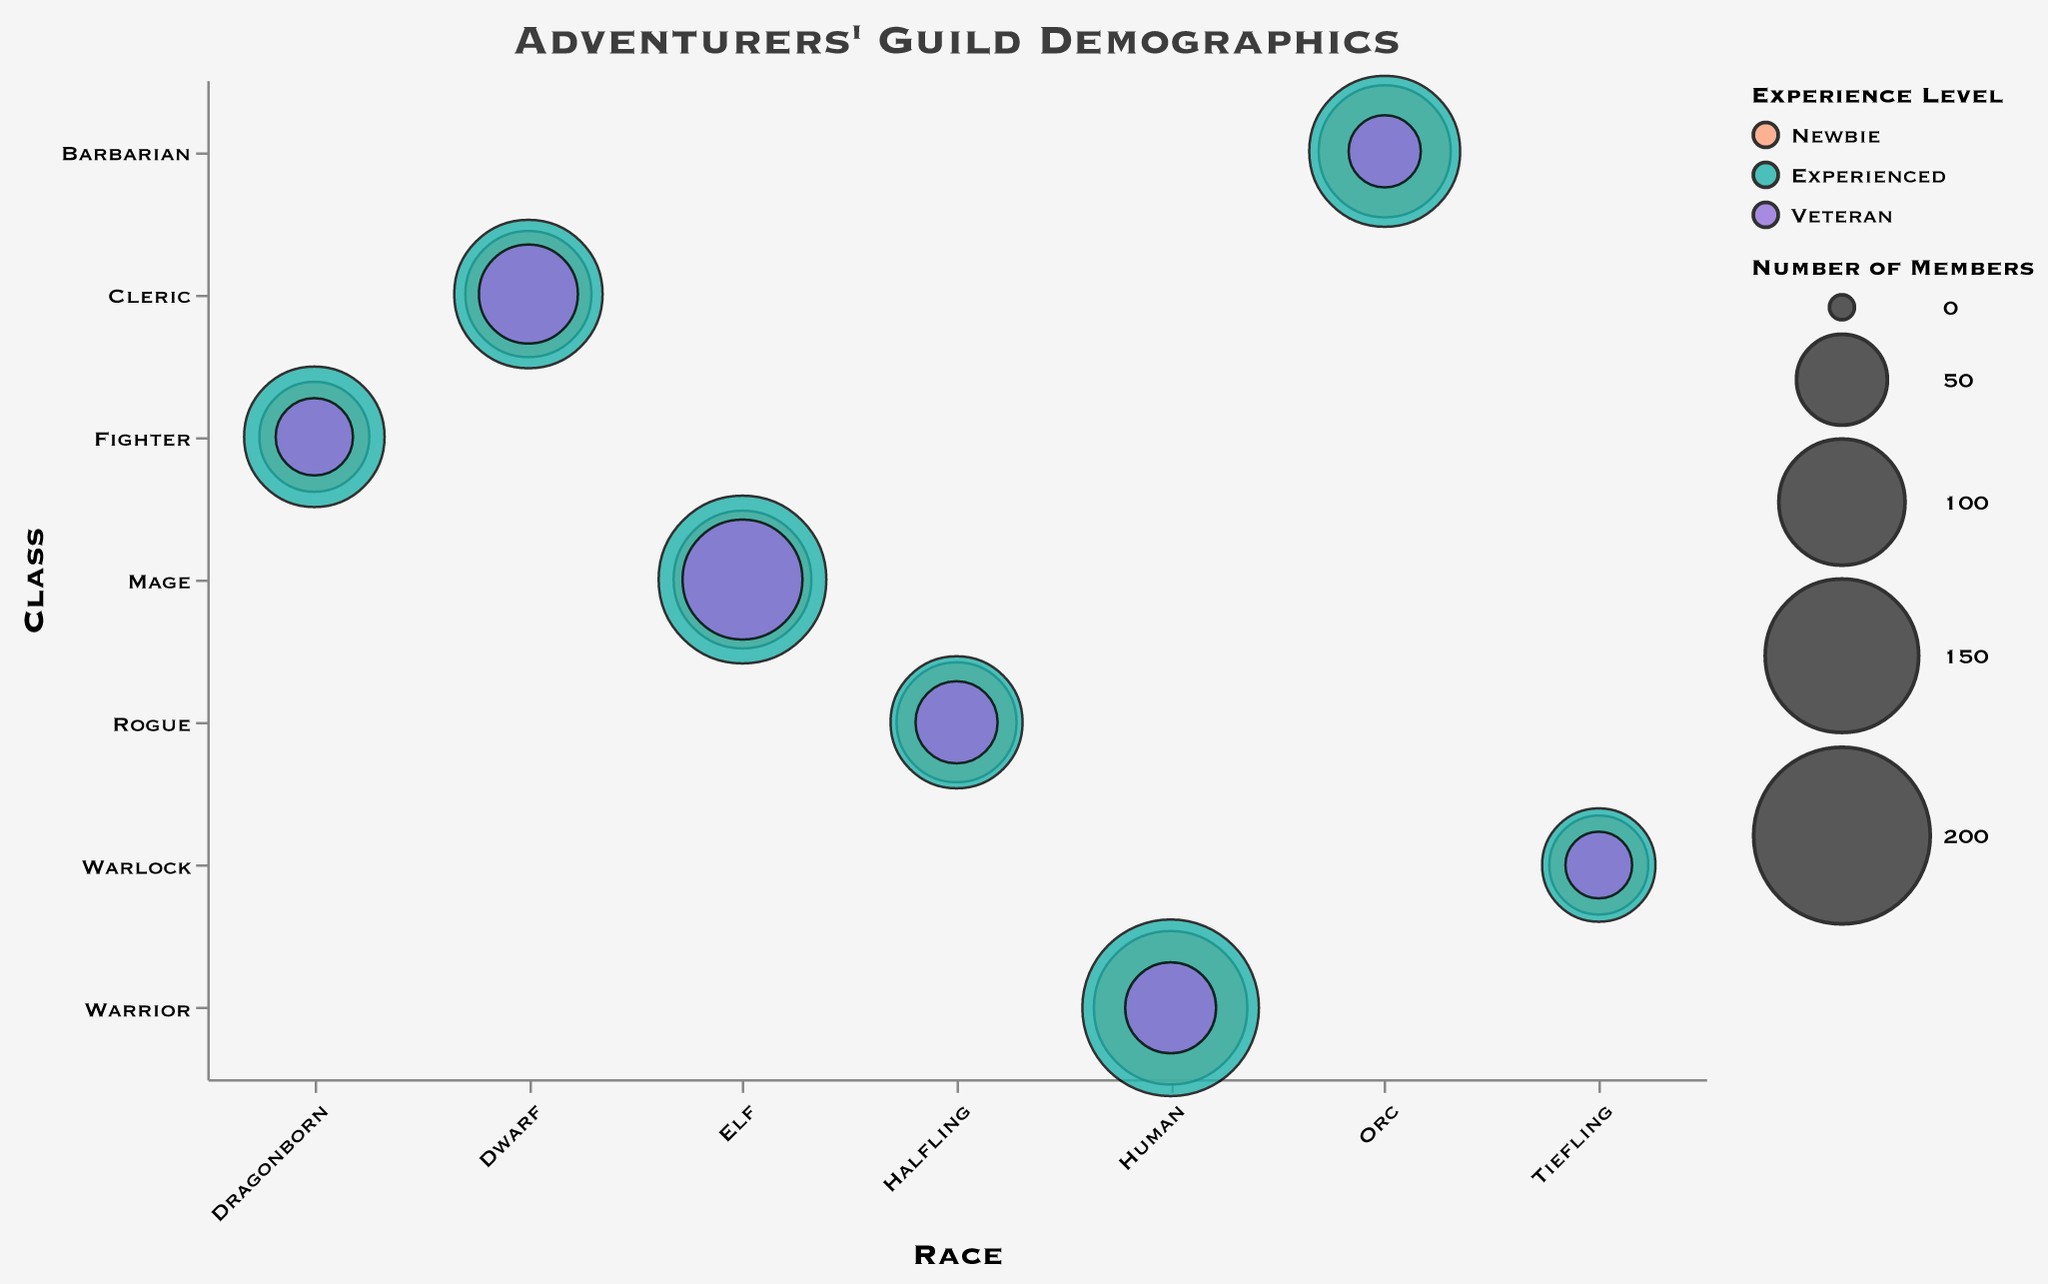What is the color representing the 'Experienced' experience level? The color for 'Experienced' experience level can be found by referring to the legend. The 'Experienced' level is shown in a teal color.
Answer: Teal How many 'Veteran' members are there in the 'Orc' race and 'Barbarian' class? Locate the bubble for the 'Orc' race and 'Barbarian' class with the 'Veteran' color. The tooltip or size will show the 'NumberOfMembers' value, which is 30.
Answer: 30 Which race-class-experience combination has the highest number of members? The largest bubble represents the highest number of members. By hovering over the largest bubble or checking the respective tooltip, we find it is the 'Human' race, 'Warrior' class, and 'Experienced' level. The 'NumberOfMembers' is 200.
Answer: Human-Warrior-Experienced Compare the number of 'Newbie' members between 'Elf' Mages and 'Human' Warriors. Which group has more members and by how much? First, identify the 'Newbie' bubbles for 'Elf' Mages and 'Human' Warriors by their position and color. The number of members for 'Elf' Mages is 120, and for 'Human' Warriors is 150. The difference is 150 - 120 = 30, so 'Human' Warriors have 30 more 'Newbie' members.
Answer: Human Warriors, by 30 What is the total number of members across all races and classes for the 'Veteran' experience level? Sum the 'NumberOfMembers' values for the 'Veteran' experience level across all race-class combinations. This includes: Human-Warrior (50), Elf-Mage (90), Dwarf-Cleric (60), Halfling-Rogue (40), Dragonborn-Fighter (35), Tiefling-Warlock (25), Orc-Barbarian (30). The total is 50 + 90 + 60 + 40 + 35 + 25 + 30 = 330.
Answer: 330 How does the 'Newbie' membership of 'Dragonborn' Fighters compare to 'Tiefling' Warlocks? Find the 'Newbie' bubbles for 'Dragonborn' Fighters and 'Tiefling' Warlocks. 'Dragonborn' Fighters have 75 members, while 'Tiefling' Warlocks have 60 members. Comparing these, 'Dragonborn' Fighters have more members.
Answer: Dragonborn Fighters have more members What are the race and class with the fewest 'Experienced' members, and how many members are there? Locate the smallest bubble for the 'Experienced' experience level across all race and class combinations. The smallest bubble is for the 'Tiefling' race and 'Warlock' class with 80 members.
Answer: Tiefling-Warlock, 80 members Which class has the highest number of total members regardless of race and experience level? Sum the 'NumberOfMembers' across all races and experience levels for each class and compare. The calculations for total are: 
- Warrior: 150 (Newbie) + 200 (Experienced) + 50 (Veteran) = 400
- Mage: 120 + 180 + 90 = 390
- Cleric: 100 + 140 + 60 = 300
- Rogue: 90 + 110 + 40 = 240
- Fighter: 75 + 125 + 35 = 235
- Warlock: 60 + 80 + 25 = 165
- Barbarian: 110 + 145 + 30 = 285
The class with the highest total is 'Warrior' with 400 members.
Answer: Warrior, 400 members How many 'Newbie' members are in the guild in total? Sum the 'NumberOfMembers' across all races and classes for the 'Newbie' experience level. This is: Human-Warrior (150), Elf-Mage (120), Dwarf-Cleric (100), Halfling-Rogue (90), Dragonborn-Fighter (75), Tiefling-Warlock (60), Orc-Barbarian (110). The total is 150 + 120 + 100 + 90 + 75 + 60 + 110 = 705.
Answer: 705 Which experience level is most common among 'Fighter' class members? Sum the 'NumberOfMembers' for the 'Fighter' class for each experience level and compare. The values are: Newbie (75), Experienced (125), Veteran (35). The most common experience level is 'Experienced' with 125 members.
Answer: Experienced 